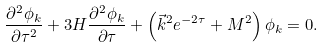Convert formula to latex. <formula><loc_0><loc_0><loc_500><loc_500>\frac { \partial ^ { 2 } \phi _ { k } } { \partial \tau ^ { 2 } } + 3 H \frac { \partial ^ { 2 } \phi _ { k } } { \partial \tau } + \left ( \vec { k } ^ { 2 } e ^ { - 2 \tau } + M ^ { 2 } \right ) \phi _ { k } = 0 .</formula> 